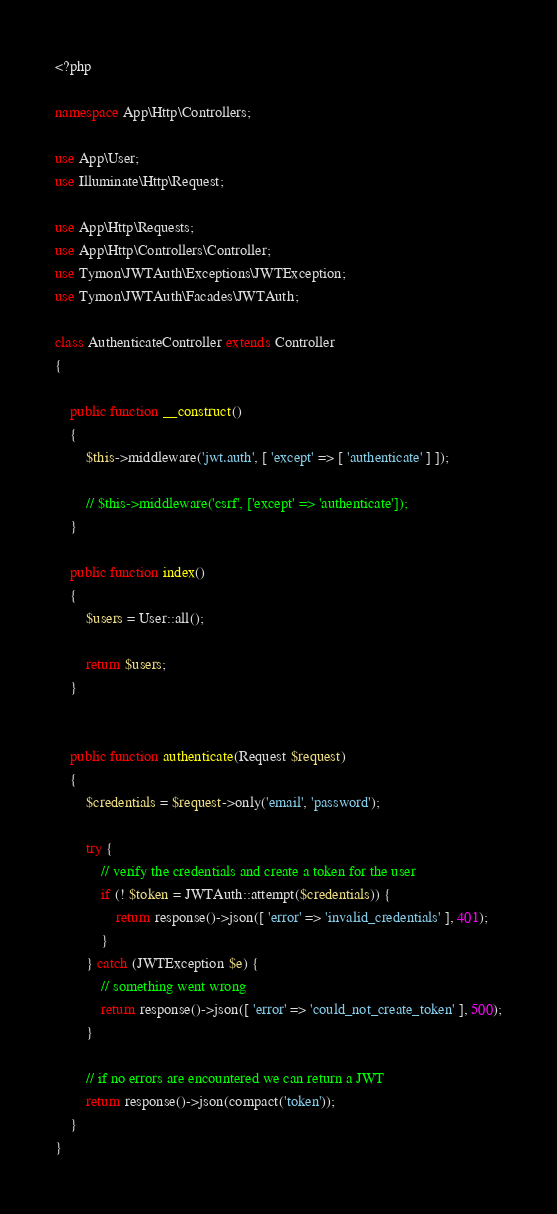Convert code to text. <code><loc_0><loc_0><loc_500><loc_500><_PHP_><?php

namespace App\Http\Controllers;

use App\User;
use Illuminate\Http\Request;

use App\Http\Requests;
use App\Http\Controllers\Controller;
use Tymon\JWTAuth\Exceptions\JWTException;
use Tymon\JWTAuth\Facades\JWTAuth;

class AuthenticateController extends Controller
{

    public function __construct()
    {
        $this->middleware('jwt.auth', [ 'except' => [ 'authenticate' ] ]);

        // $this->middleware('csrf', ['except' => 'authenticate']);
    }

    public function index()
    {
        $users = User::all();

        return $users;
    }


    public function authenticate(Request $request)
    {
        $credentials = $request->only('email', 'password');

        try {
            // verify the credentials and create a token for the user
            if (! $token = JWTAuth::attempt($credentials)) {
                return response()->json([ 'error' => 'invalid_credentials' ], 401);
            }
        } catch (JWTException $e) {
            // something went wrong
            return response()->json([ 'error' => 'could_not_create_token' ], 500);
        }

        // if no errors are encountered we can return a JWT
        return response()->json(compact('token'));
    }
}
</code> 